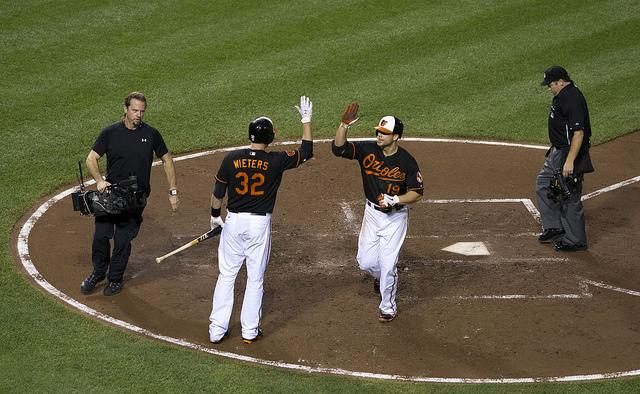Where did 19 just step away from?

Choices:
A) home base
B) bunker
C) bunk house
D) pitchers mound home base 